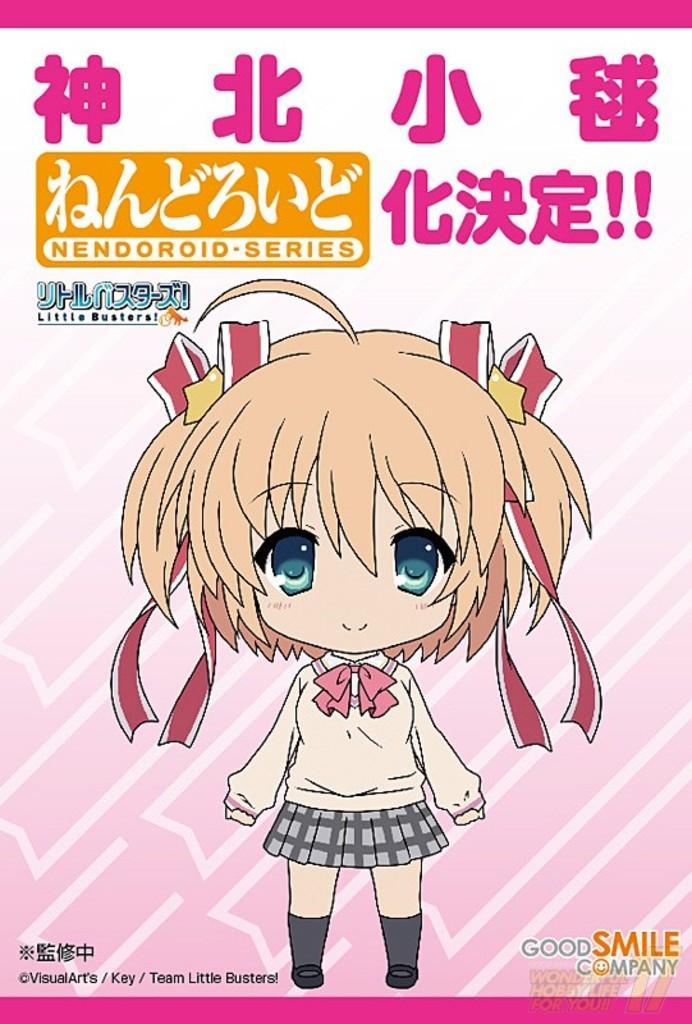How would you summarize this image in a sentence or two? This is a picture of a poster. In this picture we can see a depiction of a girl. We can see some information. 